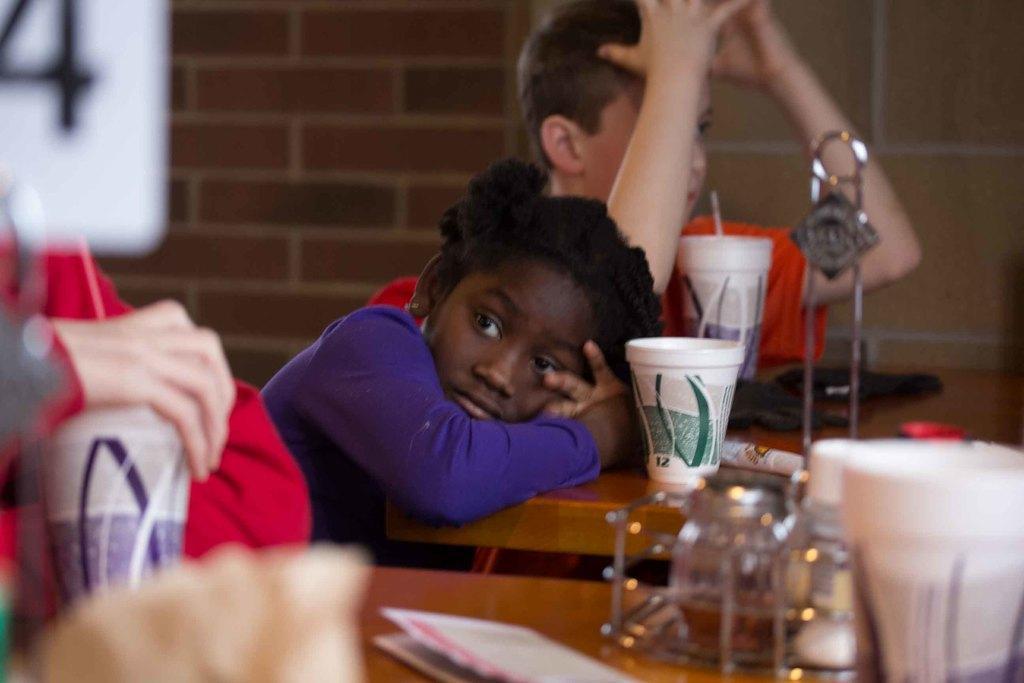Could you give a brief overview of what you see in this image? This picture shows a boy and a girl seated on the chairs and we see few cups on the table and a man holding a cup in his hand 